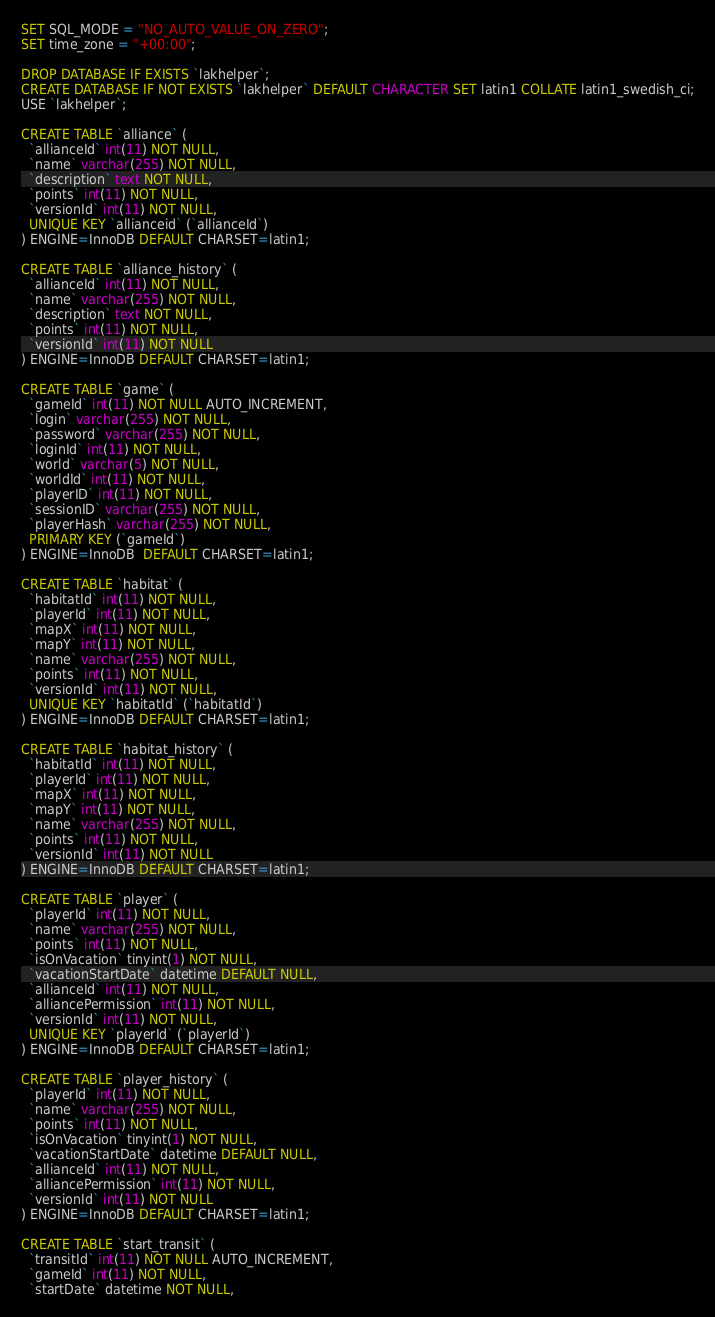<code> <loc_0><loc_0><loc_500><loc_500><_SQL_>
SET SQL_MODE = "NO_AUTO_VALUE_ON_ZERO";
SET time_zone = "+00:00";

DROP DATABASE IF EXISTS `lakhelper`;
CREATE DATABASE IF NOT EXISTS `lakhelper` DEFAULT CHARACTER SET latin1 COLLATE latin1_swedish_ci;
USE `lakhelper`;

CREATE TABLE `alliance` (
  `allianceId` int(11) NOT NULL,
  `name` varchar(255) NOT NULL,
  `description` text NOT NULL,
  `points` int(11) NOT NULL,
  `versionId` int(11) NOT NULL,
  UNIQUE KEY `allianceid` (`allianceId`)
) ENGINE=InnoDB DEFAULT CHARSET=latin1;

CREATE TABLE `alliance_history` (
  `allianceId` int(11) NOT NULL,
  `name` varchar(255) NOT NULL,
  `description` text NOT NULL,
  `points` int(11) NOT NULL,
  `versionId` int(11) NOT NULL
) ENGINE=InnoDB DEFAULT CHARSET=latin1;

CREATE TABLE `game` (
  `gameId` int(11) NOT NULL AUTO_INCREMENT,
  `login` varchar(255) NOT NULL,
  `password` varchar(255) NOT NULL,
  `loginId` int(11) NOT NULL,
  `world` varchar(5) NOT NULL,
  `worldId` int(11) NOT NULL,
  `playerID` int(11) NOT NULL,
  `sessionID` varchar(255) NOT NULL,
  `playerHash` varchar(255) NOT NULL,
  PRIMARY KEY (`gameId`)
) ENGINE=InnoDB  DEFAULT CHARSET=latin1;

CREATE TABLE `habitat` (
  `habitatId` int(11) NOT NULL,
  `playerId` int(11) NOT NULL,
  `mapX` int(11) NOT NULL,
  `mapY` int(11) NOT NULL,
  `name` varchar(255) NOT NULL,
  `points` int(11) NOT NULL,
  `versionId` int(11) NOT NULL,
  UNIQUE KEY `habitatId` (`habitatId`)
) ENGINE=InnoDB DEFAULT CHARSET=latin1;

CREATE TABLE `habitat_history` (
  `habitatId` int(11) NOT NULL,
  `playerId` int(11) NOT NULL,
  `mapX` int(11) NOT NULL,
  `mapY` int(11) NOT NULL,
  `name` varchar(255) NOT NULL,
  `points` int(11) NOT NULL,
  `versionId` int(11) NOT NULL
) ENGINE=InnoDB DEFAULT CHARSET=latin1;

CREATE TABLE `player` (
  `playerId` int(11) NOT NULL,
  `name` varchar(255) NOT NULL,
  `points` int(11) NOT NULL,
  `isOnVacation` tinyint(1) NOT NULL,
  `vacationStartDate` datetime DEFAULT NULL,
  `allianceId` int(11) NOT NULL,
  `alliancePermission` int(11) NOT NULL,
  `versionId` int(11) NOT NULL,
  UNIQUE KEY `playerId` (`playerId`)
) ENGINE=InnoDB DEFAULT CHARSET=latin1;

CREATE TABLE `player_history` (
  `playerId` int(11) NOT NULL,
  `name` varchar(255) NOT NULL,
  `points` int(11) NOT NULL,
  `isOnVacation` tinyint(1) NOT NULL,
  `vacationStartDate` datetime DEFAULT NULL,
  `allianceId` int(11) NOT NULL,
  `alliancePermission` int(11) NOT NULL,
  `versionId` int(11) NOT NULL
) ENGINE=InnoDB DEFAULT CHARSET=latin1;

CREATE TABLE `start_transit` (
  `transitId` int(11) NOT NULL AUTO_INCREMENT,
  `gameId` int(11) NOT NULL,
  `startDate` datetime NOT NULL,</code> 